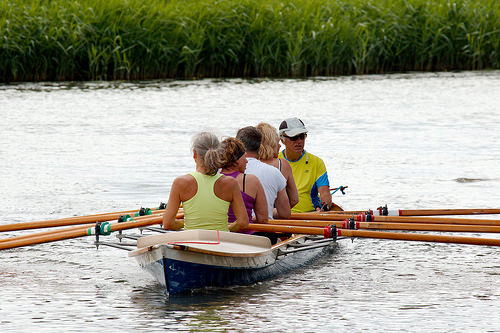<image>
Is there a purple shirt on the woman? Yes. Looking at the image, I can see the purple shirt is positioned on top of the woman, with the woman providing support. Where is the water in relation to the woman? Is it on the woman? No. The water is not positioned on the woman. They may be near each other, but the water is not supported by or resting on top of the woman. Where is the boat in relation to the lake? Is it in the lake? Yes. The boat is contained within or inside the lake, showing a containment relationship. 